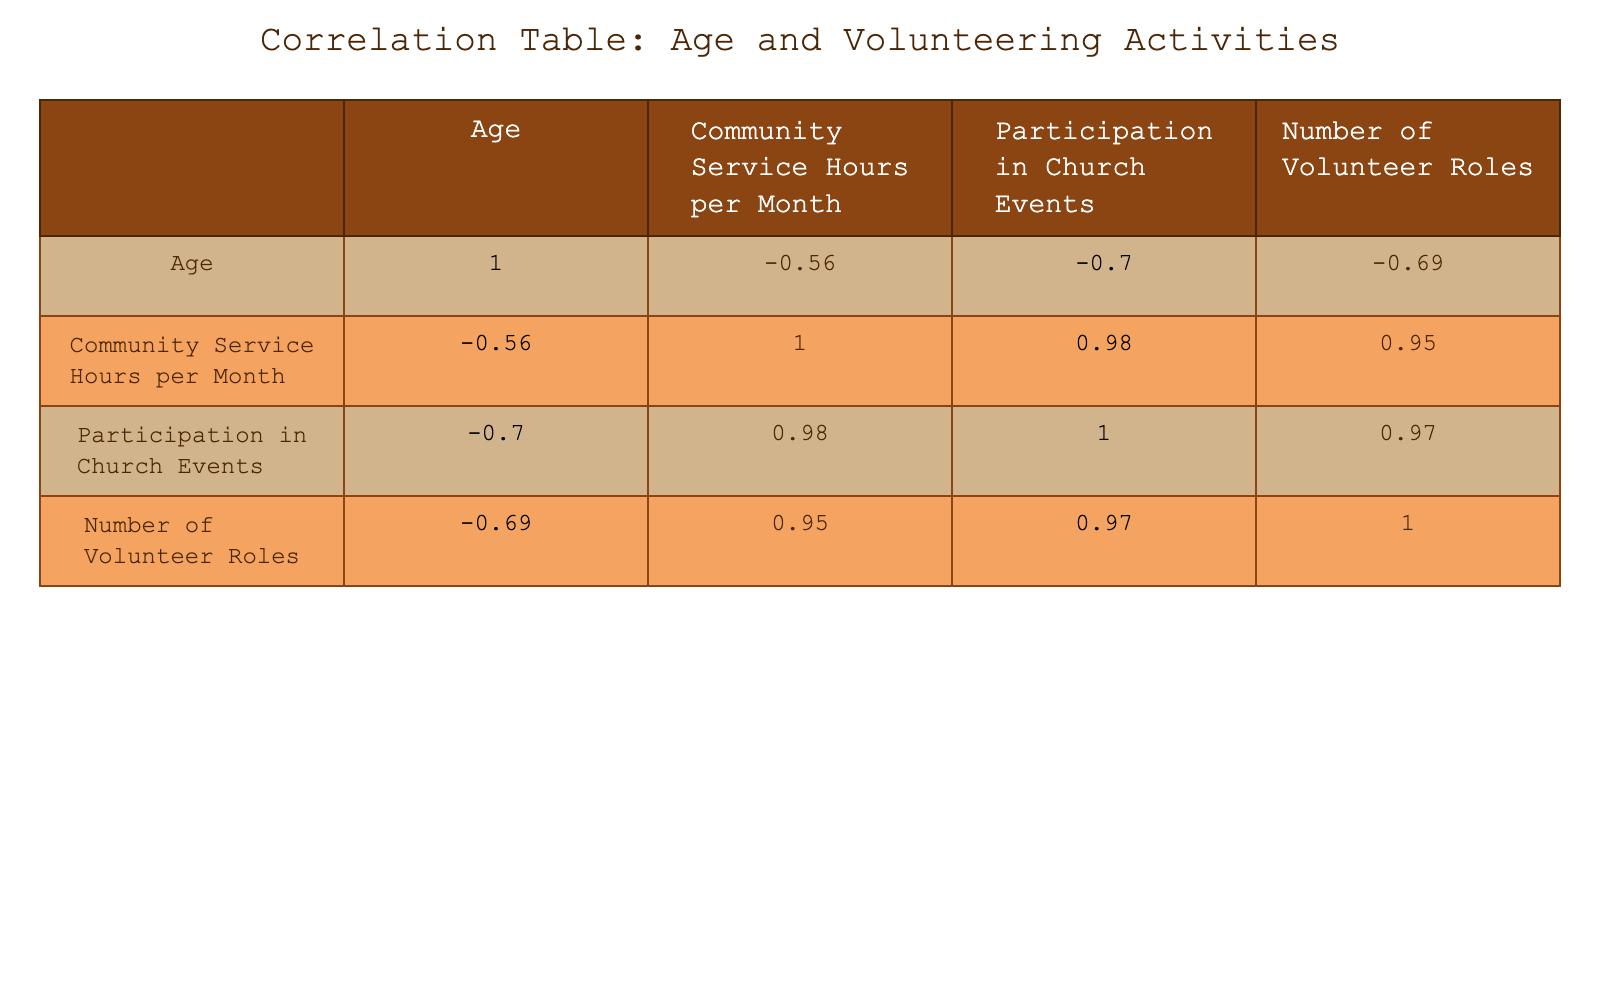What is the correlation coefficient between age and community service hours per month? The correlation coefficient between age and community service hours per month is found in the correlation table. By looking at the table, we see that the value is -0.85. This indicates a strong negative correlation, meaning as age increases, community service hours tend to decrease.
Answer: -0.85 What is the highest number of volunteer roles recorded in the data? By examining the Number of Volunteer Roles column in the table, we see that the maximum value is 5, recorded for the age of 75.
Answer: 5 Are younger individuals more likely to participate in church events compared to older individuals, based on the data? Looking at the Participation in Church Events column, younger individuals (like the 60 and 65-year-olds) have higher participation scores (5 and 6), while older individuals (like the 85 and 90-year-olds) have lower scores (2 and 1). Thus, yes, younger individuals are more likely to participate more than older individuals.
Answer: Yes What is the average number of community service hours among individuals aged 70 and above? For individuals aged 70 and above, we have the following community service hours: 12 (age 70), 20 (age 75), 8 (age 80), 6 (age 85), and 4 (age 90). Summing these values gives us 12 + 20 + 8 + 6 + 4 = 50. There are 5 individuals, so the average is 50/5 = 10.
Answer: 10 Is there a positive correlation between age and the number of volunteer roles? The correlation table shows that the correlation coefficient between age and the number of volunteer roles is -0.74, which is a negative value. Hence, this indicates that there is not a positive correlation; in fact, it's a negative correlation.
Answer: No What is the difference in community service hours per month between those aged 60 and 90? The community service hours for individuals aged 60 is 10, while for those aged 90 it is 4. Subtracting these gives us 10 - 4 = 6 hours.
Answer: 6 How many volunteer roles does a 70-year-old have compared to an 80-year-old? A 70-year-old has 2 volunteer roles, while an 80-year-old has 1. The difference is 2 - 1 = 1 role. Thus, a 70-year-old has 1 more volunteer role than an 80-year-old.
Answer: 1 What is the total number of participation hours for individuals aged 75 and above? The participation in church events for individuals aged 75 and above are: 8 (age 75), 3 (age 80), 2 (age 85), and 1 (age 90). We sum these values: 8 + 3 + 2 + 1 = 14.
Answer: 14 